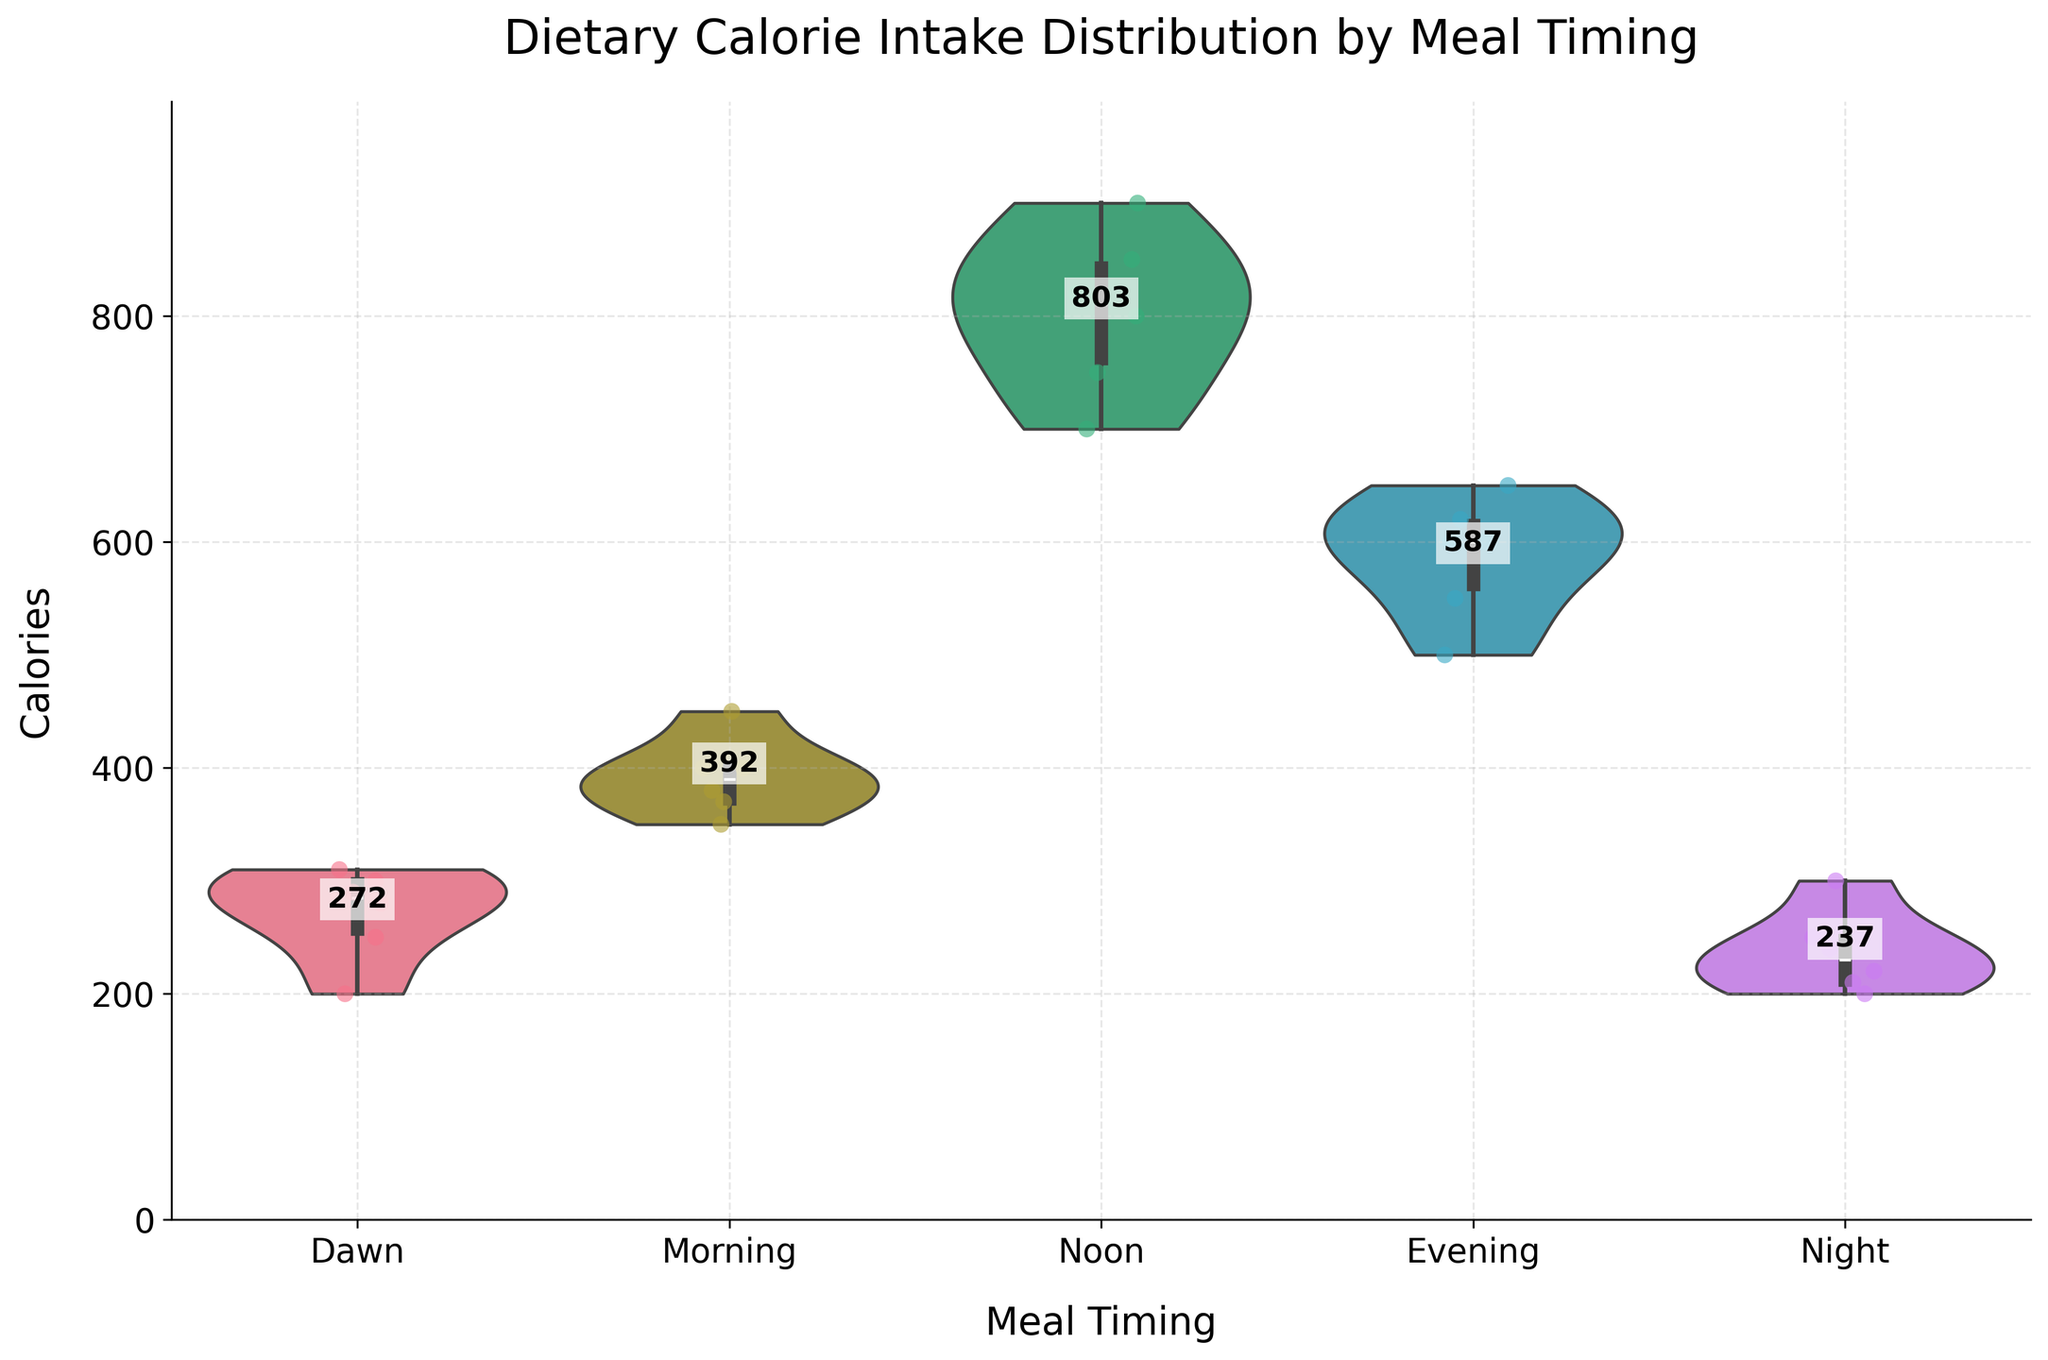What is the title of the figure? The title is displayed at the top of the figure. It typically summarizes what the figure is about.
Answer: Dietary Calorie Intake Distribution by Meal Timing What is the maximum number of calories consumed in any meal? To determine this, look at the highest point in the distribution across all meal timings on the y-axis.
Answer: 900 Which meal timing has the highest average calorie intake? The mean calorie intake for each meal timing is annotated as a text label on the figure. Identify the highest of these mean values.
Answer: Noon How many different meal timings are shown? Count the number of distinct categories on the x-axis, which represent different meal timings.
Answer: 5 Which meal timing has the lowest variance in calorie intake? By analyzing the width of the violin plots for each meal timing, the one with the narrowest spread indicates the lowest variance.
Answer: Dawn How do the calorie intake patterns differ between Morning and Evening meals? Compare the shapes, center points, and spreads of the violin plots and jittered points for Morning and Evening meals.
Answer: The Evening meal has a higher spread and higher average calories compared to the Morning meal What is the range of calorie intakes observed for Night meals? Identify the minimum and maximum y-values within the Night meal violin plot to determine the range.
Answer: 200-300 How does the calorie intake at Noon compare to other meal timings? Observe the Noon violin plot for its width and center point compared to other timings, plus read the annotated mean value.
Answer: Noon has the highest average calorie intake and a wide spread, indicating high variance Is there any meal timing that shows a clear bimodal distribution in calorie intake? Look for violin plots with two distinct peaks or modes in their distribution shape.
Answer: No clear bimodal distribution is observed Who has the maximum jittered point for the Noon meal? By inspecting the jittered points superimposed on the Noon violin plot and identifying the highest point among them.
Answer: Anna 